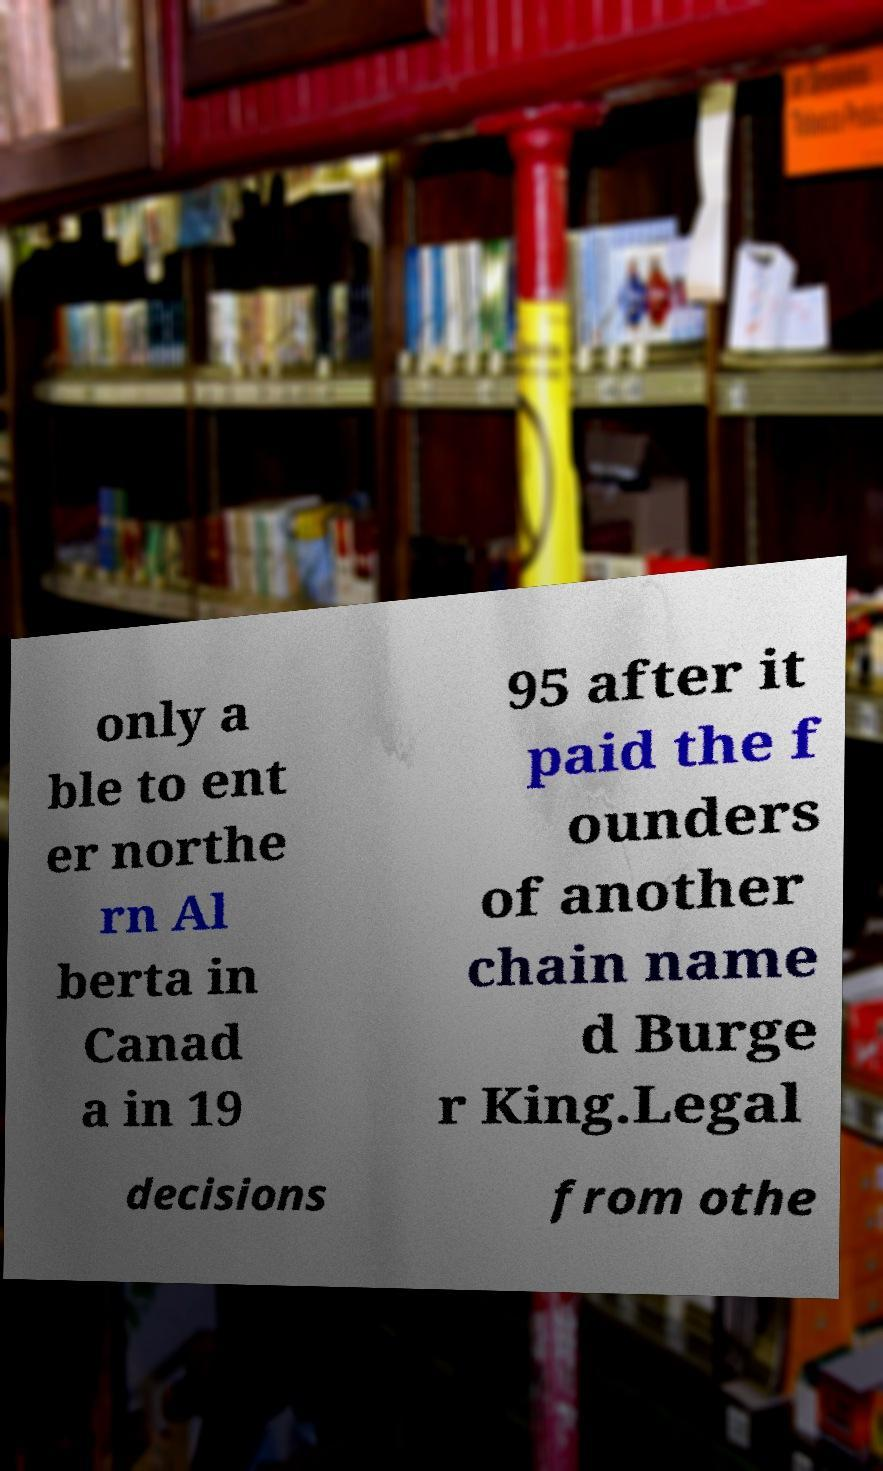There's text embedded in this image that I need extracted. Can you transcribe it verbatim? only a ble to ent er northe rn Al berta in Canad a in 19 95 after it paid the f ounders of another chain name d Burge r King.Legal decisions from othe 